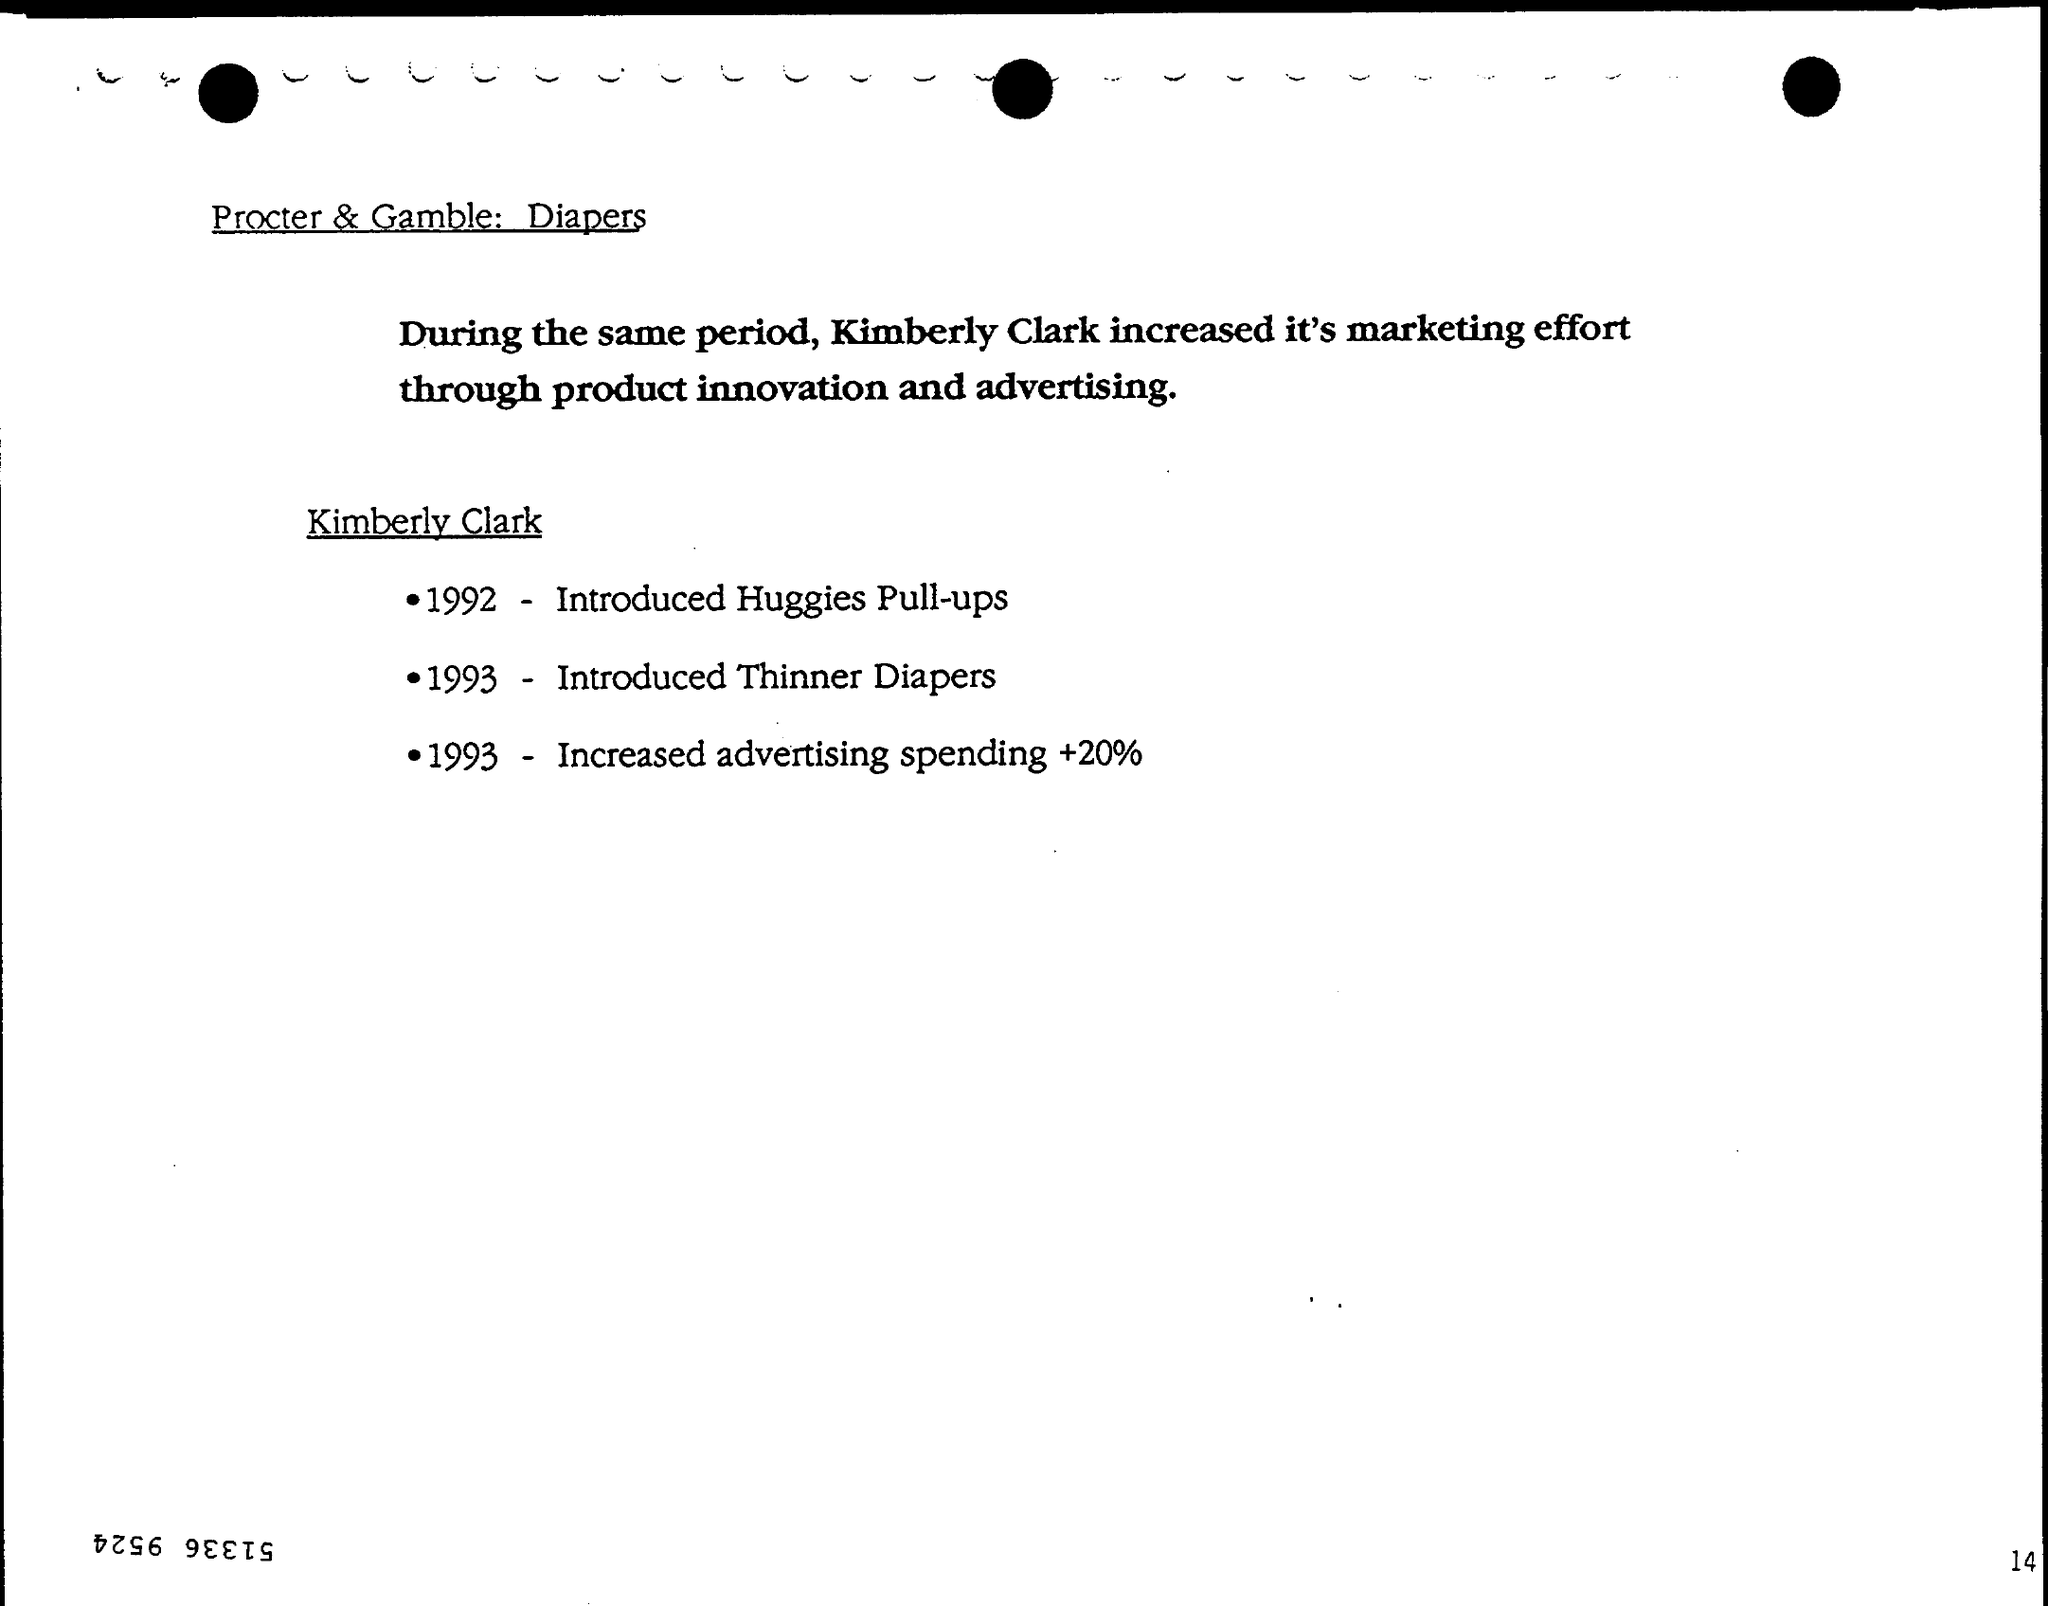When was Huggies Pull-ups Introduced?
Your answer should be compact. 1992. When were Thinner Diapers introduced?
Your answer should be compact. 1993. When was advertising spending Increased +20%?
Give a very brief answer. 1993. 